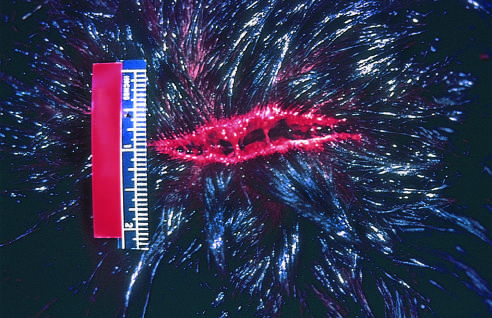re the bridging strands of fibrous tissues evident?
Answer the question using a single word or phrase. Yes 